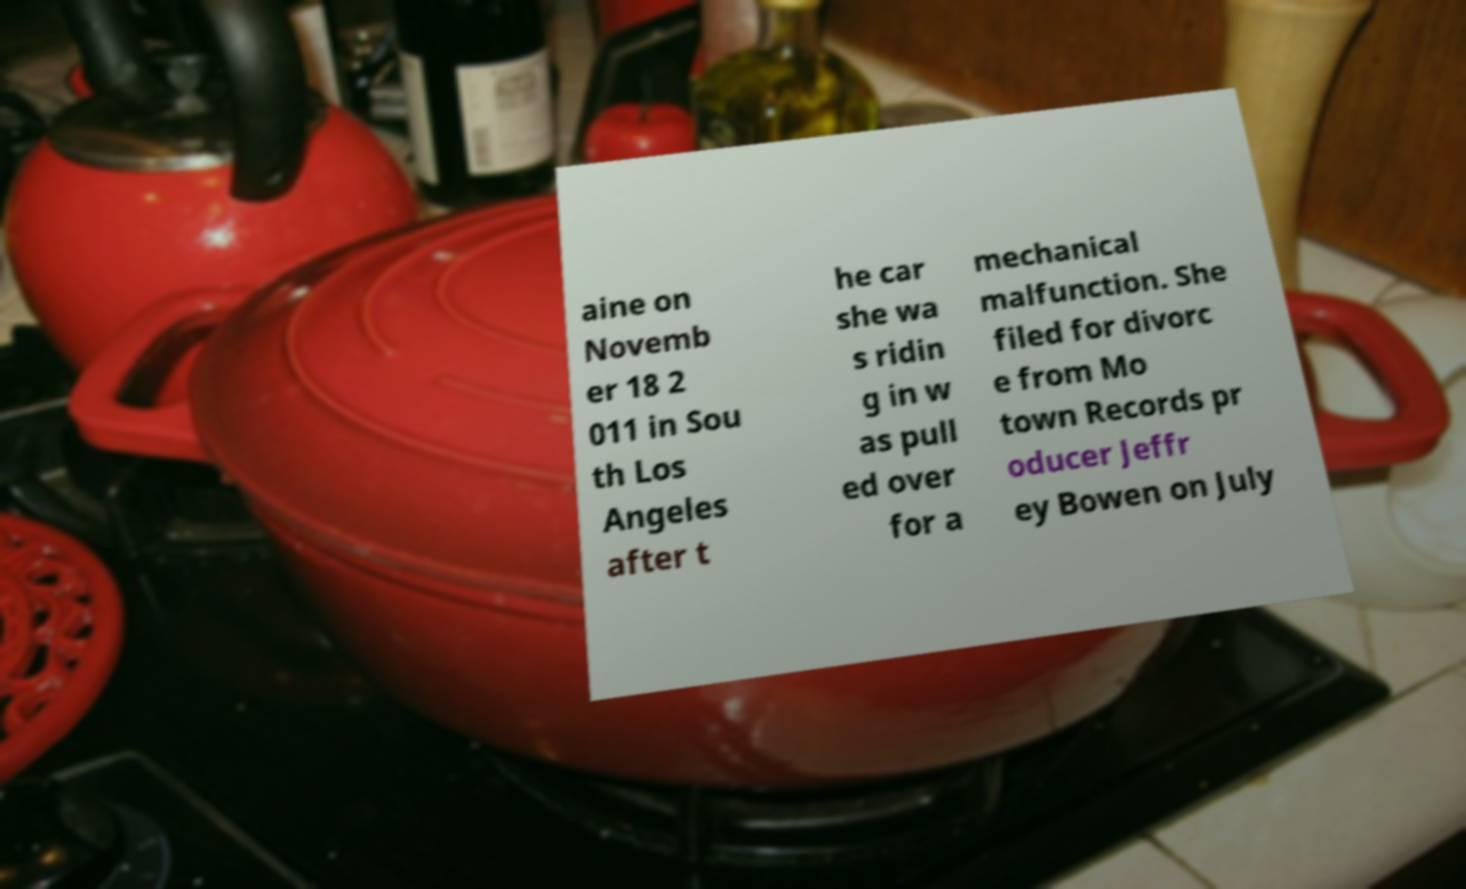Please read and relay the text visible in this image. What does it say? aine on Novemb er 18 2 011 in Sou th Los Angeles after t he car she wa s ridin g in w as pull ed over for a mechanical malfunction. She filed for divorc e from Mo town Records pr oducer Jeffr ey Bowen on July 